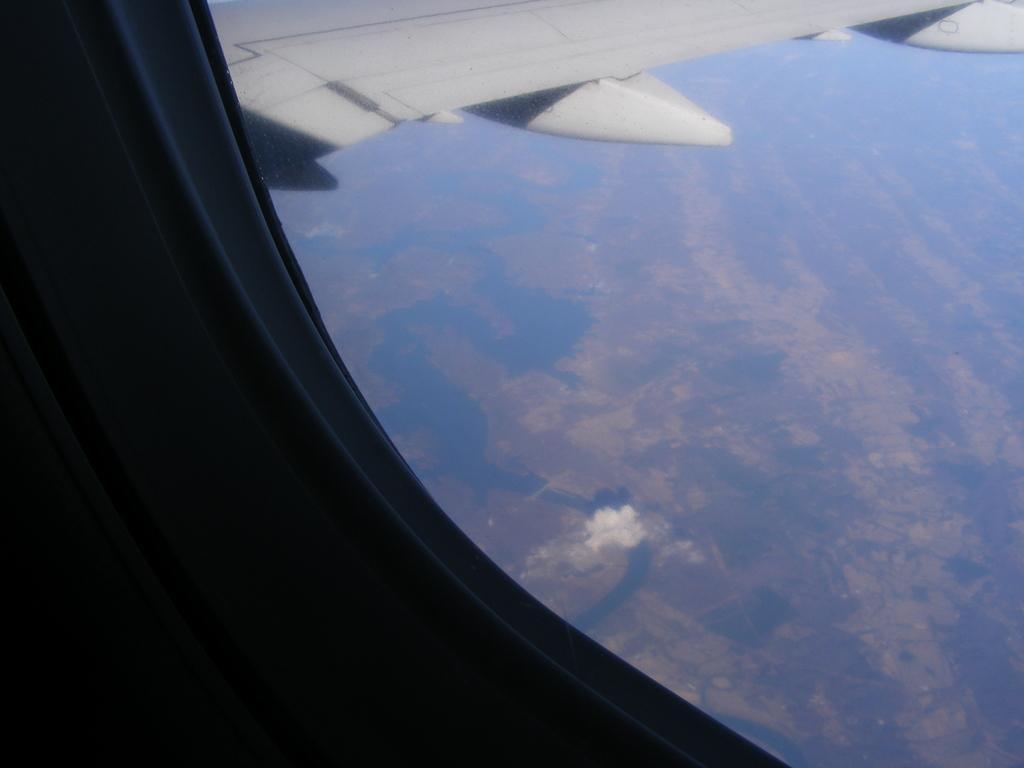In one or two sentences, can you explain what this image depicts? In this image I can see a aeroplane window. It is in white color. 